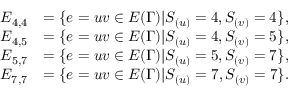Convert formula to latex. <formula><loc_0><loc_0><loc_500><loc_500>\begin{array} { r l } { E _ { 4 , 4 } } & { = \{ e = u v \in E ( \Gamma ) | S _ { ( u ) } = 4 , S _ { ( v ) } = 4 \} , } \\ { E _ { 4 , 5 } } & { = \{ e = u v \in E ( \Gamma ) | S _ { ( u ) } = 4 , S _ { ( v ) } = 5 \} , } \\ { E _ { 5 , 7 } } & { = \{ e = u v \in E ( \Gamma ) | S _ { ( u ) } = 5 , S _ { ( v ) } = 7 \} , } \\ { E _ { 7 , 7 } } & { = \{ e = u v \in E ( \Gamma ) | S _ { ( u ) } = 7 , S _ { ( v ) } = 7 \} . } \end{array}</formula> 